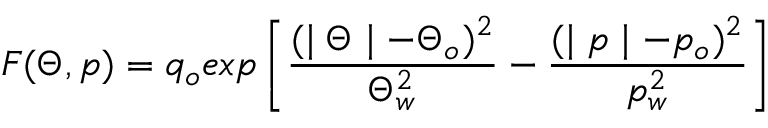<formula> <loc_0><loc_0><loc_500><loc_500>F ( \Theta , p ) = q _ { o } e x p \left [ \frac { ( | \Theta | - \Theta _ { o } ) ^ { 2 } } { \Theta _ { w } ^ { 2 } } - \frac { ( | p | - p _ { o } ) ^ { 2 } } { p _ { w } ^ { 2 } } \right ]</formula> 